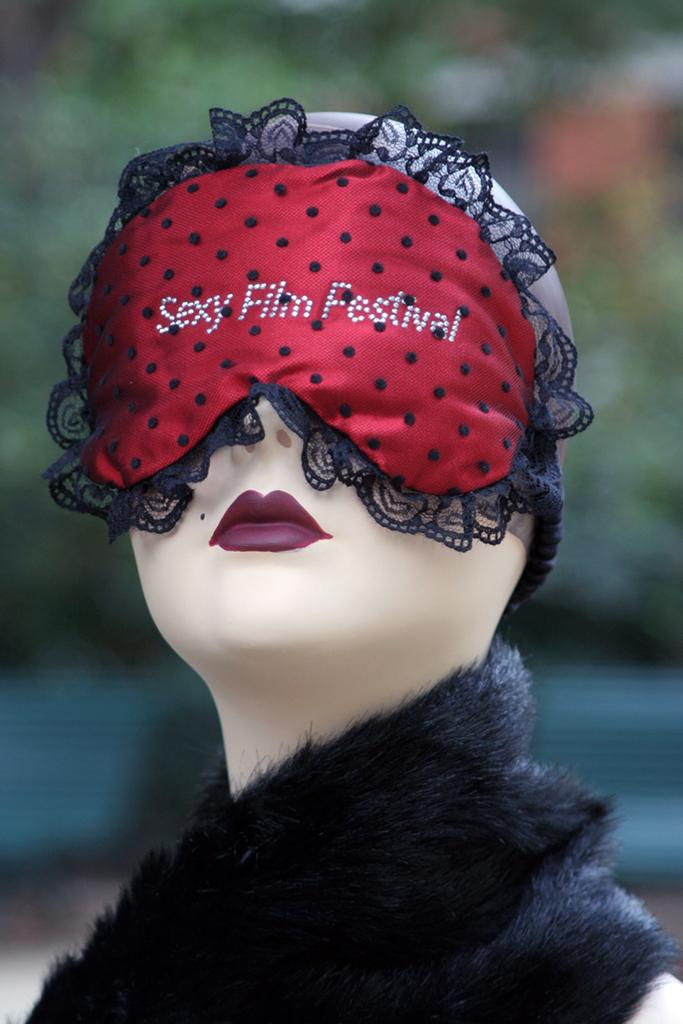What is the main subject in the middle of the image? There is a mannequin in the middle of the image. What is covering the mannequin's eyes? The mannequin's eyes are covered with a mask. What color can be seen in the background of the image? There is a green color visible in the background of the image. What type of comb is the mannequin using to help style its hair in the image? There is no comb or hair visible in the image, as the mannequin is covered with a mask. 